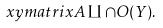<formula> <loc_0><loc_0><loc_500><loc_500>\ x y m a t r i x { A \amalg \cap O ( Y ) . }</formula> 